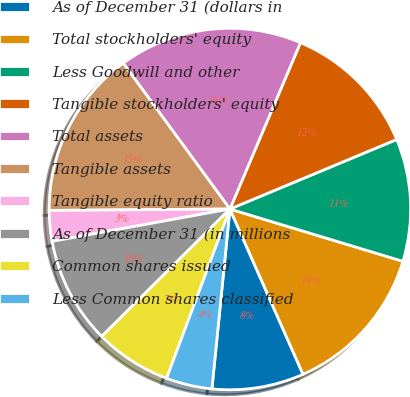Convert chart to OTSL. <chart><loc_0><loc_0><loc_500><loc_500><pie_chart><fcel>As of December 31 (dollars in<fcel>Total stockholders' equity<fcel>Less Goodwill and other<fcel>Tangible stockholders' equity<fcel>Total assets<fcel>Tangible assets<fcel>Tangible equity ratio<fcel>As of December 31 (in millions<fcel>Common shares issued<fcel>Less Common shares classified<nl><fcel>8.22%<fcel>13.7%<fcel>10.96%<fcel>12.33%<fcel>16.44%<fcel>15.07%<fcel>2.74%<fcel>9.59%<fcel>6.85%<fcel>4.11%<nl></chart> 